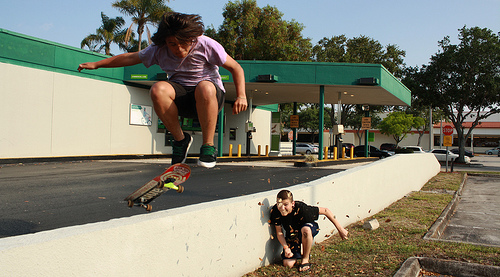Please provide the bounding box coordinate of the region this sentence describes: shoes are black with white soles. The coordinates [0.32, 0.48, 0.44, 0.57] effectively locate the black shoes with white soles worn by the skateboarder, detailed enough to distinguish from other elements. 